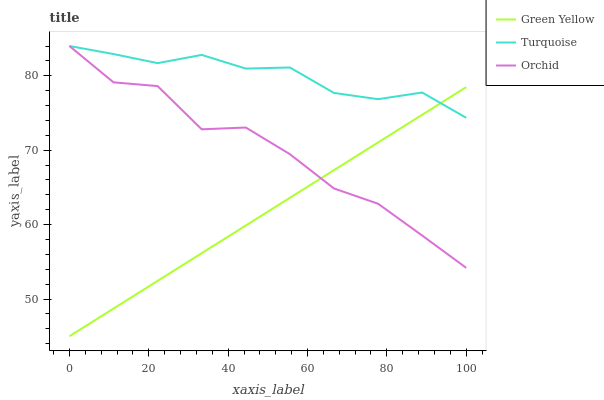Does Green Yellow have the minimum area under the curve?
Answer yes or no. Yes. Does Turquoise have the maximum area under the curve?
Answer yes or no. Yes. Does Orchid have the minimum area under the curve?
Answer yes or no. No. Does Orchid have the maximum area under the curve?
Answer yes or no. No. Is Green Yellow the smoothest?
Answer yes or no. Yes. Is Orchid the roughest?
Answer yes or no. Yes. Is Orchid the smoothest?
Answer yes or no. No. Is Green Yellow the roughest?
Answer yes or no. No. Does Green Yellow have the lowest value?
Answer yes or no. Yes. Does Orchid have the lowest value?
Answer yes or no. No. Does Orchid have the highest value?
Answer yes or no. Yes. Does Green Yellow have the highest value?
Answer yes or no. No. Does Orchid intersect Green Yellow?
Answer yes or no. Yes. Is Orchid less than Green Yellow?
Answer yes or no. No. Is Orchid greater than Green Yellow?
Answer yes or no. No. 